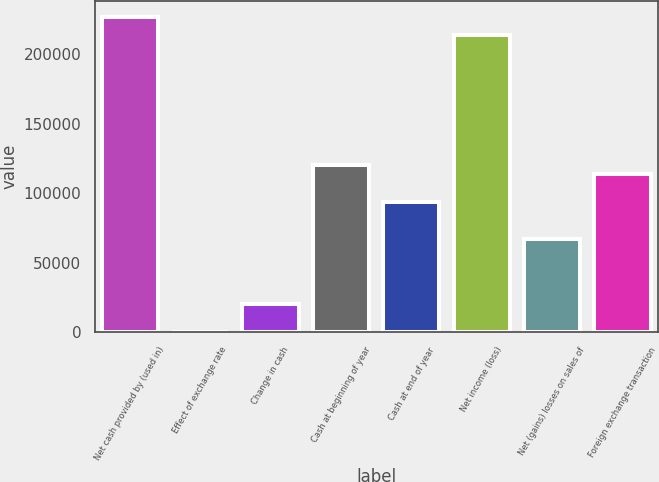Convert chart to OTSL. <chart><loc_0><loc_0><loc_500><loc_500><bar_chart><fcel>Net cash provided by (used in)<fcel>Effect of exchange rate<fcel>Change in cash<fcel>Cash at beginning of year<fcel>Cash at end of year<fcel>Net income (loss)<fcel>Net (gains) losses on sales of<fcel>Foreign exchange transaction<nl><fcel>227234<fcel>114<fcel>20154<fcel>120354<fcel>93634<fcel>213874<fcel>66914<fcel>113674<nl></chart> 